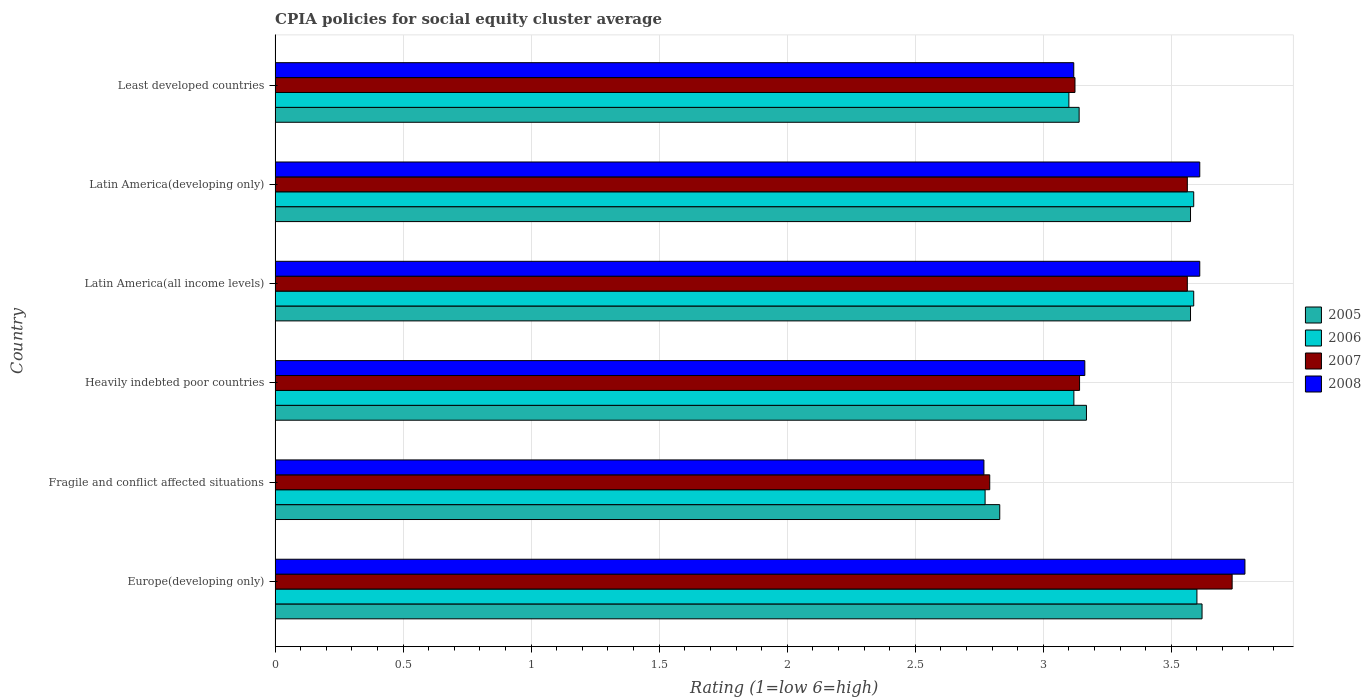How many groups of bars are there?
Offer a terse response. 6. How many bars are there on the 5th tick from the top?
Offer a terse response. 4. What is the label of the 5th group of bars from the top?
Provide a short and direct response. Fragile and conflict affected situations. What is the CPIA rating in 2008 in Heavily indebted poor countries?
Your answer should be compact. 3.16. Across all countries, what is the maximum CPIA rating in 2008?
Ensure brevity in your answer.  3.79. Across all countries, what is the minimum CPIA rating in 2005?
Your response must be concise. 2.83. In which country was the CPIA rating in 2005 maximum?
Make the answer very short. Europe(developing only). In which country was the CPIA rating in 2005 minimum?
Your answer should be very brief. Fragile and conflict affected situations. What is the total CPIA rating in 2006 in the graph?
Offer a terse response. 19.77. What is the difference between the CPIA rating in 2008 in Fragile and conflict affected situations and that in Latin America(all income levels)?
Give a very brief answer. -0.84. What is the difference between the CPIA rating in 2006 in Latin America(all income levels) and the CPIA rating in 2005 in Latin America(developing only)?
Ensure brevity in your answer.  0.01. What is the average CPIA rating in 2005 per country?
Make the answer very short. 3.32. What is the difference between the CPIA rating in 2008 and CPIA rating in 2006 in Least developed countries?
Offer a very short reply. 0.02. What is the ratio of the CPIA rating in 2006 in Europe(developing only) to that in Latin America(developing only)?
Offer a very short reply. 1. Is the CPIA rating in 2008 in Latin America(developing only) less than that in Least developed countries?
Make the answer very short. No. What is the difference between the highest and the second highest CPIA rating in 2008?
Keep it short and to the point. 0.18. What is the difference between the highest and the lowest CPIA rating in 2007?
Your response must be concise. 0.95. Is it the case that in every country, the sum of the CPIA rating in 2006 and CPIA rating in 2005 is greater than the sum of CPIA rating in 2008 and CPIA rating in 2007?
Your answer should be very brief. No. What does the 2nd bar from the top in Heavily indebted poor countries represents?
Ensure brevity in your answer.  2007. Is it the case that in every country, the sum of the CPIA rating in 2006 and CPIA rating in 2007 is greater than the CPIA rating in 2008?
Provide a short and direct response. Yes. How many bars are there?
Your response must be concise. 24. How many countries are there in the graph?
Keep it short and to the point. 6. Does the graph contain any zero values?
Your answer should be very brief. No. Does the graph contain grids?
Keep it short and to the point. Yes. Where does the legend appear in the graph?
Your answer should be compact. Center right. How are the legend labels stacked?
Your response must be concise. Vertical. What is the title of the graph?
Your response must be concise. CPIA policies for social equity cluster average. Does "1986" appear as one of the legend labels in the graph?
Keep it short and to the point. No. What is the label or title of the X-axis?
Make the answer very short. Rating (1=low 6=high). What is the Rating (1=low 6=high) in 2005 in Europe(developing only)?
Keep it short and to the point. 3.62. What is the Rating (1=low 6=high) in 2006 in Europe(developing only)?
Provide a short and direct response. 3.6. What is the Rating (1=low 6=high) of 2007 in Europe(developing only)?
Offer a very short reply. 3.74. What is the Rating (1=low 6=high) of 2008 in Europe(developing only)?
Give a very brief answer. 3.79. What is the Rating (1=low 6=high) in 2005 in Fragile and conflict affected situations?
Keep it short and to the point. 2.83. What is the Rating (1=low 6=high) in 2006 in Fragile and conflict affected situations?
Your answer should be compact. 2.77. What is the Rating (1=low 6=high) in 2007 in Fragile and conflict affected situations?
Give a very brief answer. 2.79. What is the Rating (1=low 6=high) in 2008 in Fragile and conflict affected situations?
Provide a succinct answer. 2.77. What is the Rating (1=low 6=high) in 2005 in Heavily indebted poor countries?
Offer a terse response. 3.17. What is the Rating (1=low 6=high) in 2006 in Heavily indebted poor countries?
Give a very brief answer. 3.12. What is the Rating (1=low 6=high) of 2007 in Heavily indebted poor countries?
Your response must be concise. 3.14. What is the Rating (1=low 6=high) of 2008 in Heavily indebted poor countries?
Your response must be concise. 3.16. What is the Rating (1=low 6=high) in 2005 in Latin America(all income levels)?
Offer a terse response. 3.58. What is the Rating (1=low 6=high) in 2006 in Latin America(all income levels)?
Offer a terse response. 3.59. What is the Rating (1=low 6=high) in 2007 in Latin America(all income levels)?
Ensure brevity in your answer.  3.56. What is the Rating (1=low 6=high) in 2008 in Latin America(all income levels)?
Provide a succinct answer. 3.61. What is the Rating (1=low 6=high) in 2005 in Latin America(developing only)?
Your answer should be compact. 3.58. What is the Rating (1=low 6=high) in 2006 in Latin America(developing only)?
Your response must be concise. 3.59. What is the Rating (1=low 6=high) in 2007 in Latin America(developing only)?
Your answer should be compact. 3.56. What is the Rating (1=low 6=high) in 2008 in Latin America(developing only)?
Provide a succinct answer. 3.61. What is the Rating (1=low 6=high) of 2005 in Least developed countries?
Offer a terse response. 3.14. What is the Rating (1=low 6=high) in 2007 in Least developed countries?
Provide a short and direct response. 3.12. What is the Rating (1=low 6=high) in 2008 in Least developed countries?
Ensure brevity in your answer.  3.12. Across all countries, what is the maximum Rating (1=low 6=high) of 2005?
Ensure brevity in your answer.  3.62. Across all countries, what is the maximum Rating (1=low 6=high) of 2006?
Provide a short and direct response. 3.6. Across all countries, what is the maximum Rating (1=low 6=high) in 2007?
Your response must be concise. 3.74. Across all countries, what is the maximum Rating (1=low 6=high) in 2008?
Provide a succinct answer. 3.79. Across all countries, what is the minimum Rating (1=low 6=high) in 2005?
Provide a short and direct response. 2.83. Across all countries, what is the minimum Rating (1=low 6=high) of 2006?
Provide a short and direct response. 2.77. Across all countries, what is the minimum Rating (1=low 6=high) in 2007?
Your answer should be very brief. 2.79. Across all countries, what is the minimum Rating (1=low 6=high) of 2008?
Offer a terse response. 2.77. What is the total Rating (1=low 6=high) of 2005 in the graph?
Offer a very short reply. 19.91. What is the total Rating (1=low 6=high) of 2006 in the graph?
Offer a terse response. 19.77. What is the total Rating (1=low 6=high) in 2007 in the graph?
Your answer should be compact. 19.92. What is the total Rating (1=low 6=high) in 2008 in the graph?
Your response must be concise. 20.06. What is the difference between the Rating (1=low 6=high) in 2005 in Europe(developing only) and that in Fragile and conflict affected situations?
Your answer should be very brief. 0.79. What is the difference between the Rating (1=low 6=high) of 2006 in Europe(developing only) and that in Fragile and conflict affected situations?
Offer a terse response. 0.83. What is the difference between the Rating (1=low 6=high) in 2007 in Europe(developing only) and that in Fragile and conflict affected situations?
Provide a short and direct response. 0.95. What is the difference between the Rating (1=low 6=high) of 2008 in Europe(developing only) and that in Fragile and conflict affected situations?
Make the answer very short. 1.02. What is the difference between the Rating (1=low 6=high) in 2005 in Europe(developing only) and that in Heavily indebted poor countries?
Offer a terse response. 0.45. What is the difference between the Rating (1=low 6=high) in 2006 in Europe(developing only) and that in Heavily indebted poor countries?
Your answer should be compact. 0.48. What is the difference between the Rating (1=low 6=high) in 2007 in Europe(developing only) and that in Heavily indebted poor countries?
Give a very brief answer. 0.6. What is the difference between the Rating (1=low 6=high) in 2008 in Europe(developing only) and that in Heavily indebted poor countries?
Offer a terse response. 0.63. What is the difference between the Rating (1=low 6=high) of 2005 in Europe(developing only) and that in Latin America(all income levels)?
Provide a short and direct response. 0.04. What is the difference between the Rating (1=low 6=high) in 2006 in Europe(developing only) and that in Latin America(all income levels)?
Make the answer very short. 0.01. What is the difference between the Rating (1=low 6=high) of 2007 in Europe(developing only) and that in Latin America(all income levels)?
Offer a terse response. 0.17. What is the difference between the Rating (1=low 6=high) of 2008 in Europe(developing only) and that in Latin America(all income levels)?
Your answer should be very brief. 0.18. What is the difference between the Rating (1=low 6=high) of 2005 in Europe(developing only) and that in Latin America(developing only)?
Offer a very short reply. 0.04. What is the difference between the Rating (1=low 6=high) of 2006 in Europe(developing only) and that in Latin America(developing only)?
Offer a terse response. 0.01. What is the difference between the Rating (1=low 6=high) in 2007 in Europe(developing only) and that in Latin America(developing only)?
Give a very brief answer. 0.17. What is the difference between the Rating (1=low 6=high) in 2008 in Europe(developing only) and that in Latin America(developing only)?
Provide a short and direct response. 0.18. What is the difference between the Rating (1=low 6=high) of 2005 in Europe(developing only) and that in Least developed countries?
Offer a very short reply. 0.48. What is the difference between the Rating (1=low 6=high) of 2006 in Europe(developing only) and that in Least developed countries?
Give a very brief answer. 0.5. What is the difference between the Rating (1=low 6=high) in 2007 in Europe(developing only) and that in Least developed countries?
Offer a terse response. 0.61. What is the difference between the Rating (1=low 6=high) of 2008 in Europe(developing only) and that in Least developed countries?
Your answer should be very brief. 0.67. What is the difference between the Rating (1=low 6=high) of 2005 in Fragile and conflict affected situations and that in Heavily indebted poor countries?
Offer a terse response. -0.34. What is the difference between the Rating (1=low 6=high) in 2006 in Fragile and conflict affected situations and that in Heavily indebted poor countries?
Offer a very short reply. -0.35. What is the difference between the Rating (1=low 6=high) of 2007 in Fragile and conflict affected situations and that in Heavily indebted poor countries?
Provide a short and direct response. -0.35. What is the difference between the Rating (1=low 6=high) of 2008 in Fragile and conflict affected situations and that in Heavily indebted poor countries?
Give a very brief answer. -0.39. What is the difference between the Rating (1=low 6=high) in 2005 in Fragile and conflict affected situations and that in Latin America(all income levels)?
Offer a very short reply. -0.74. What is the difference between the Rating (1=low 6=high) in 2006 in Fragile and conflict affected situations and that in Latin America(all income levels)?
Provide a succinct answer. -0.81. What is the difference between the Rating (1=low 6=high) of 2007 in Fragile and conflict affected situations and that in Latin America(all income levels)?
Your answer should be compact. -0.77. What is the difference between the Rating (1=low 6=high) in 2008 in Fragile and conflict affected situations and that in Latin America(all income levels)?
Provide a short and direct response. -0.84. What is the difference between the Rating (1=low 6=high) of 2005 in Fragile and conflict affected situations and that in Latin America(developing only)?
Keep it short and to the point. -0.74. What is the difference between the Rating (1=low 6=high) of 2006 in Fragile and conflict affected situations and that in Latin America(developing only)?
Offer a terse response. -0.81. What is the difference between the Rating (1=low 6=high) in 2007 in Fragile and conflict affected situations and that in Latin America(developing only)?
Ensure brevity in your answer.  -0.77. What is the difference between the Rating (1=low 6=high) of 2008 in Fragile and conflict affected situations and that in Latin America(developing only)?
Offer a very short reply. -0.84. What is the difference between the Rating (1=low 6=high) of 2005 in Fragile and conflict affected situations and that in Least developed countries?
Provide a succinct answer. -0.31. What is the difference between the Rating (1=low 6=high) in 2006 in Fragile and conflict affected situations and that in Least developed countries?
Make the answer very short. -0.33. What is the difference between the Rating (1=low 6=high) of 2007 in Fragile and conflict affected situations and that in Least developed countries?
Your answer should be very brief. -0.33. What is the difference between the Rating (1=low 6=high) in 2008 in Fragile and conflict affected situations and that in Least developed countries?
Provide a short and direct response. -0.35. What is the difference between the Rating (1=low 6=high) in 2005 in Heavily indebted poor countries and that in Latin America(all income levels)?
Your response must be concise. -0.41. What is the difference between the Rating (1=low 6=high) in 2006 in Heavily indebted poor countries and that in Latin America(all income levels)?
Your response must be concise. -0.47. What is the difference between the Rating (1=low 6=high) of 2007 in Heavily indebted poor countries and that in Latin America(all income levels)?
Give a very brief answer. -0.42. What is the difference between the Rating (1=low 6=high) in 2008 in Heavily indebted poor countries and that in Latin America(all income levels)?
Your answer should be compact. -0.45. What is the difference between the Rating (1=low 6=high) of 2005 in Heavily indebted poor countries and that in Latin America(developing only)?
Keep it short and to the point. -0.41. What is the difference between the Rating (1=low 6=high) in 2006 in Heavily indebted poor countries and that in Latin America(developing only)?
Your answer should be very brief. -0.47. What is the difference between the Rating (1=low 6=high) of 2007 in Heavily indebted poor countries and that in Latin America(developing only)?
Your response must be concise. -0.42. What is the difference between the Rating (1=low 6=high) of 2008 in Heavily indebted poor countries and that in Latin America(developing only)?
Ensure brevity in your answer.  -0.45. What is the difference between the Rating (1=low 6=high) of 2005 in Heavily indebted poor countries and that in Least developed countries?
Provide a succinct answer. 0.03. What is the difference between the Rating (1=low 6=high) in 2006 in Heavily indebted poor countries and that in Least developed countries?
Provide a short and direct response. 0.02. What is the difference between the Rating (1=low 6=high) of 2007 in Heavily indebted poor countries and that in Least developed countries?
Your answer should be compact. 0.02. What is the difference between the Rating (1=low 6=high) of 2008 in Heavily indebted poor countries and that in Least developed countries?
Make the answer very short. 0.04. What is the difference between the Rating (1=low 6=high) of 2005 in Latin America(all income levels) and that in Latin America(developing only)?
Offer a terse response. 0. What is the difference between the Rating (1=low 6=high) of 2006 in Latin America(all income levels) and that in Latin America(developing only)?
Offer a terse response. 0. What is the difference between the Rating (1=low 6=high) of 2008 in Latin America(all income levels) and that in Latin America(developing only)?
Provide a short and direct response. 0. What is the difference between the Rating (1=low 6=high) of 2005 in Latin America(all income levels) and that in Least developed countries?
Your response must be concise. 0.43. What is the difference between the Rating (1=low 6=high) of 2006 in Latin America(all income levels) and that in Least developed countries?
Ensure brevity in your answer.  0.49. What is the difference between the Rating (1=low 6=high) in 2007 in Latin America(all income levels) and that in Least developed countries?
Make the answer very short. 0.44. What is the difference between the Rating (1=low 6=high) of 2008 in Latin America(all income levels) and that in Least developed countries?
Provide a succinct answer. 0.49. What is the difference between the Rating (1=low 6=high) in 2005 in Latin America(developing only) and that in Least developed countries?
Your answer should be very brief. 0.43. What is the difference between the Rating (1=low 6=high) of 2006 in Latin America(developing only) and that in Least developed countries?
Offer a terse response. 0.49. What is the difference between the Rating (1=low 6=high) of 2007 in Latin America(developing only) and that in Least developed countries?
Offer a terse response. 0.44. What is the difference between the Rating (1=low 6=high) of 2008 in Latin America(developing only) and that in Least developed countries?
Your answer should be compact. 0.49. What is the difference between the Rating (1=low 6=high) of 2005 in Europe(developing only) and the Rating (1=low 6=high) of 2006 in Fragile and conflict affected situations?
Offer a terse response. 0.85. What is the difference between the Rating (1=low 6=high) in 2005 in Europe(developing only) and the Rating (1=low 6=high) in 2007 in Fragile and conflict affected situations?
Keep it short and to the point. 0.83. What is the difference between the Rating (1=low 6=high) in 2005 in Europe(developing only) and the Rating (1=low 6=high) in 2008 in Fragile and conflict affected situations?
Offer a terse response. 0.85. What is the difference between the Rating (1=low 6=high) in 2006 in Europe(developing only) and the Rating (1=low 6=high) in 2007 in Fragile and conflict affected situations?
Your answer should be very brief. 0.81. What is the difference between the Rating (1=low 6=high) in 2006 in Europe(developing only) and the Rating (1=low 6=high) in 2008 in Fragile and conflict affected situations?
Ensure brevity in your answer.  0.83. What is the difference between the Rating (1=low 6=high) in 2007 in Europe(developing only) and the Rating (1=low 6=high) in 2008 in Fragile and conflict affected situations?
Give a very brief answer. 0.97. What is the difference between the Rating (1=low 6=high) in 2005 in Europe(developing only) and the Rating (1=low 6=high) in 2006 in Heavily indebted poor countries?
Your answer should be very brief. 0.5. What is the difference between the Rating (1=low 6=high) in 2005 in Europe(developing only) and the Rating (1=low 6=high) in 2007 in Heavily indebted poor countries?
Make the answer very short. 0.48. What is the difference between the Rating (1=low 6=high) in 2005 in Europe(developing only) and the Rating (1=low 6=high) in 2008 in Heavily indebted poor countries?
Ensure brevity in your answer.  0.46. What is the difference between the Rating (1=low 6=high) in 2006 in Europe(developing only) and the Rating (1=low 6=high) in 2007 in Heavily indebted poor countries?
Keep it short and to the point. 0.46. What is the difference between the Rating (1=low 6=high) in 2006 in Europe(developing only) and the Rating (1=low 6=high) in 2008 in Heavily indebted poor countries?
Your response must be concise. 0.44. What is the difference between the Rating (1=low 6=high) in 2007 in Europe(developing only) and the Rating (1=low 6=high) in 2008 in Heavily indebted poor countries?
Your response must be concise. 0.58. What is the difference between the Rating (1=low 6=high) of 2005 in Europe(developing only) and the Rating (1=low 6=high) of 2006 in Latin America(all income levels)?
Provide a short and direct response. 0.03. What is the difference between the Rating (1=low 6=high) of 2005 in Europe(developing only) and the Rating (1=low 6=high) of 2007 in Latin America(all income levels)?
Your answer should be compact. 0.06. What is the difference between the Rating (1=low 6=high) of 2005 in Europe(developing only) and the Rating (1=low 6=high) of 2008 in Latin America(all income levels)?
Your response must be concise. 0.01. What is the difference between the Rating (1=low 6=high) of 2006 in Europe(developing only) and the Rating (1=low 6=high) of 2007 in Latin America(all income levels)?
Offer a very short reply. 0.04. What is the difference between the Rating (1=low 6=high) in 2006 in Europe(developing only) and the Rating (1=low 6=high) in 2008 in Latin America(all income levels)?
Keep it short and to the point. -0.01. What is the difference between the Rating (1=low 6=high) in 2007 in Europe(developing only) and the Rating (1=low 6=high) in 2008 in Latin America(all income levels)?
Offer a terse response. 0.13. What is the difference between the Rating (1=low 6=high) of 2005 in Europe(developing only) and the Rating (1=low 6=high) of 2006 in Latin America(developing only)?
Make the answer very short. 0.03. What is the difference between the Rating (1=low 6=high) of 2005 in Europe(developing only) and the Rating (1=low 6=high) of 2007 in Latin America(developing only)?
Provide a succinct answer. 0.06. What is the difference between the Rating (1=low 6=high) in 2005 in Europe(developing only) and the Rating (1=low 6=high) in 2008 in Latin America(developing only)?
Offer a terse response. 0.01. What is the difference between the Rating (1=low 6=high) in 2006 in Europe(developing only) and the Rating (1=low 6=high) in 2007 in Latin America(developing only)?
Your response must be concise. 0.04. What is the difference between the Rating (1=low 6=high) of 2006 in Europe(developing only) and the Rating (1=low 6=high) of 2008 in Latin America(developing only)?
Provide a succinct answer. -0.01. What is the difference between the Rating (1=low 6=high) in 2007 in Europe(developing only) and the Rating (1=low 6=high) in 2008 in Latin America(developing only)?
Offer a terse response. 0.13. What is the difference between the Rating (1=low 6=high) in 2005 in Europe(developing only) and the Rating (1=low 6=high) in 2006 in Least developed countries?
Give a very brief answer. 0.52. What is the difference between the Rating (1=low 6=high) of 2005 in Europe(developing only) and the Rating (1=low 6=high) of 2007 in Least developed countries?
Your response must be concise. 0.5. What is the difference between the Rating (1=low 6=high) in 2005 in Europe(developing only) and the Rating (1=low 6=high) in 2008 in Least developed countries?
Your answer should be very brief. 0.5. What is the difference between the Rating (1=low 6=high) in 2006 in Europe(developing only) and the Rating (1=low 6=high) in 2007 in Least developed countries?
Keep it short and to the point. 0.48. What is the difference between the Rating (1=low 6=high) in 2006 in Europe(developing only) and the Rating (1=low 6=high) in 2008 in Least developed countries?
Offer a terse response. 0.48. What is the difference between the Rating (1=low 6=high) of 2007 in Europe(developing only) and the Rating (1=low 6=high) of 2008 in Least developed countries?
Ensure brevity in your answer.  0.62. What is the difference between the Rating (1=low 6=high) in 2005 in Fragile and conflict affected situations and the Rating (1=low 6=high) in 2006 in Heavily indebted poor countries?
Offer a very short reply. -0.29. What is the difference between the Rating (1=low 6=high) of 2005 in Fragile and conflict affected situations and the Rating (1=low 6=high) of 2007 in Heavily indebted poor countries?
Provide a short and direct response. -0.31. What is the difference between the Rating (1=low 6=high) of 2005 in Fragile and conflict affected situations and the Rating (1=low 6=high) of 2008 in Heavily indebted poor countries?
Your answer should be compact. -0.33. What is the difference between the Rating (1=low 6=high) in 2006 in Fragile and conflict affected situations and the Rating (1=low 6=high) in 2007 in Heavily indebted poor countries?
Offer a terse response. -0.37. What is the difference between the Rating (1=low 6=high) in 2006 in Fragile and conflict affected situations and the Rating (1=low 6=high) in 2008 in Heavily indebted poor countries?
Make the answer very short. -0.39. What is the difference between the Rating (1=low 6=high) in 2007 in Fragile and conflict affected situations and the Rating (1=low 6=high) in 2008 in Heavily indebted poor countries?
Your answer should be very brief. -0.37. What is the difference between the Rating (1=low 6=high) of 2005 in Fragile and conflict affected situations and the Rating (1=low 6=high) of 2006 in Latin America(all income levels)?
Your answer should be compact. -0.76. What is the difference between the Rating (1=low 6=high) in 2005 in Fragile and conflict affected situations and the Rating (1=low 6=high) in 2007 in Latin America(all income levels)?
Offer a terse response. -0.73. What is the difference between the Rating (1=low 6=high) of 2005 in Fragile and conflict affected situations and the Rating (1=low 6=high) of 2008 in Latin America(all income levels)?
Offer a very short reply. -0.78. What is the difference between the Rating (1=low 6=high) of 2006 in Fragile and conflict affected situations and the Rating (1=low 6=high) of 2007 in Latin America(all income levels)?
Offer a terse response. -0.79. What is the difference between the Rating (1=low 6=high) of 2006 in Fragile and conflict affected situations and the Rating (1=low 6=high) of 2008 in Latin America(all income levels)?
Your answer should be very brief. -0.84. What is the difference between the Rating (1=low 6=high) of 2007 in Fragile and conflict affected situations and the Rating (1=low 6=high) of 2008 in Latin America(all income levels)?
Your response must be concise. -0.82. What is the difference between the Rating (1=low 6=high) in 2005 in Fragile and conflict affected situations and the Rating (1=low 6=high) in 2006 in Latin America(developing only)?
Give a very brief answer. -0.76. What is the difference between the Rating (1=low 6=high) of 2005 in Fragile and conflict affected situations and the Rating (1=low 6=high) of 2007 in Latin America(developing only)?
Keep it short and to the point. -0.73. What is the difference between the Rating (1=low 6=high) in 2005 in Fragile and conflict affected situations and the Rating (1=low 6=high) in 2008 in Latin America(developing only)?
Provide a short and direct response. -0.78. What is the difference between the Rating (1=low 6=high) in 2006 in Fragile and conflict affected situations and the Rating (1=low 6=high) in 2007 in Latin America(developing only)?
Provide a short and direct response. -0.79. What is the difference between the Rating (1=low 6=high) of 2006 in Fragile and conflict affected situations and the Rating (1=low 6=high) of 2008 in Latin America(developing only)?
Your answer should be compact. -0.84. What is the difference between the Rating (1=low 6=high) in 2007 in Fragile and conflict affected situations and the Rating (1=low 6=high) in 2008 in Latin America(developing only)?
Provide a short and direct response. -0.82. What is the difference between the Rating (1=low 6=high) of 2005 in Fragile and conflict affected situations and the Rating (1=low 6=high) of 2006 in Least developed countries?
Offer a very short reply. -0.27. What is the difference between the Rating (1=low 6=high) in 2005 in Fragile and conflict affected situations and the Rating (1=low 6=high) in 2007 in Least developed countries?
Offer a terse response. -0.29. What is the difference between the Rating (1=low 6=high) in 2005 in Fragile and conflict affected situations and the Rating (1=low 6=high) in 2008 in Least developed countries?
Make the answer very short. -0.29. What is the difference between the Rating (1=low 6=high) of 2006 in Fragile and conflict affected situations and the Rating (1=low 6=high) of 2007 in Least developed countries?
Ensure brevity in your answer.  -0.35. What is the difference between the Rating (1=low 6=high) of 2006 in Fragile and conflict affected situations and the Rating (1=low 6=high) of 2008 in Least developed countries?
Your answer should be very brief. -0.35. What is the difference between the Rating (1=low 6=high) of 2007 in Fragile and conflict affected situations and the Rating (1=low 6=high) of 2008 in Least developed countries?
Make the answer very short. -0.33. What is the difference between the Rating (1=low 6=high) in 2005 in Heavily indebted poor countries and the Rating (1=low 6=high) in 2006 in Latin America(all income levels)?
Your answer should be very brief. -0.42. What is the difference between the Rating (1=low 6=high) of 2005 in Heavily indebted poor countries and the Rating (1=low 6=high) of 2007 in Latin America(all income levels)?
Make the answer very short. -0.39. What is the difference between the Rating (1=low 6=high) in 2005 in Heavily indebted poor countries and the Rating (1=low 6=high) in 2008 in Latin America(all income levels)?
Offer a terse response. -0.44. What is the difference between the Rating (1=low 6=high) in 2006 in Heavily indebted poor countries and the Rating (1=low 6=high) in 2007 in Latin America(all income levels)?
Keep it short and to the point. -0.44. What is the difference between the Rating (1=low 6=high) in 2006 in Heavily indebted poor countries and the Rating (1=low 6=high) in 2008 in Latin America(all income levels)?
Provide a short and direct response. -0.49. What is the difference between the Rating (1=low 6=high) of 2007 in Heavily indebted poor countries and the Rating (1=low 6=high) of 2008 in Latin America(all income levels)?
Provide a succinct answer. -0.47. What is the difference between the Rating (1=low 6=high) of 2005 in Heavily indebted poor countries and the Rating (1=low 6=high) of 2006 in Latin America(developing only)?
Keep it short and to the point. -0.42. What is the difference between the Rating (1=low 6=high) in 2005 in Heavily indebted poor countries and the Rating (1=low 6=high) in 2007 in Latin America(developing only)?
Offer a very short reply. -0.39. What is the difference between the Rating (1=low 6=high) of 2005 in Heavily indebted poor countries and the Rating (1=low 6=high) of 2008 in Latin America(developing only)?
Offer a very short reply. -0.44. What is the difference between the Rating (1=low 6=high) in 2006 in Heavily indebted poor countries and the Rating (1=low 6=high) in 2007 in Latin America(developing only)?
Offer a very short reply. -0.44. What is the difference between the Rating (1=low 6=high) of 2006 in Heavily indebted poor countries and the Rating (1=low 6=high) of 2008 in Latin America(developing only)?
Offer a very short reply. -0.49. What is the difference between the Rating (1=low 6=high) in 2007 in Heavily indebted poor countries and the Rating (1=low 6=high) in 2008 in Latin America(developing only)?
Offer a terse response. -0.47. What is the difference between the Rating (1=low 6=high) of 2005 in Heavily indebted poor countries and the Rating (1=low 6=high) of 2006 in Least developed countries?
Your answer should be very brief. 0.07. What is the difference between the Rating (1=low 6=high) of 2005 in Heavily indebted poor countries and the Rating (1=low 6=high) of 2007 in Least developed countries?
Ensure brevity in your answer.  0.04. What is the difference between the Rating (1=low 6=high) of 2005 in Heavily indebted poor countries and the Rating (1=low 6=high) of 2008 in Least developed countries?
Make the answer very short. 0.05. What is the difference between the Rating (1=low 6=high) in 2006 in Heavily indebted poor countries and the Rating (1=low 6=high) in 2007 in Least developed countries?
Provide a short and direct response. -0. What is the difference between the Rating (1=low 6=high) in 2006 in Heavily indebted poor countries and the Rating (1=low 6=high) in 2008 in Least developed countries?
Your answer should be compact. 0. What is the difference between the Rating (1=low 6=high) of 2007 in Heavily indebted poor countries and the Rating (1=low 6=high) of 2008 in Least developed countries?
Keep it short and to the point. 0.02. What is the difference between the Rating (1=low 6=high) of 2005 in Latin America(all income levels) and the Rating (1=low 6=high) of 2006 in Latin America(developing only)?
Offer a very short reply. -0.01. What is the difference between the Rating (1=low 6=high) of 2005 in Latin America(all income levels) and the Rating (1=low 6=high) of 2007 in Latin America(developing only)?
Offer a terse response. 0.01. What is the difference between the Rating (1=low 6=high) of 2005 in Latin America(all income levels) and the Rating (1=low 6=high) of 2008 in Latin America(developing only)?
Provide a short and direct response. -0.04. What is the difference between the Rating (1=low 6=high) of 2006 in Latin America(all income levels) and the Rating (1=low 6=high) of 2007 in Latin America(developing only)?
Your answer should be very brief. 0.03. What is the difference between the Rating (1=low 6=high) in 2006 in Latin America(all income levels) and the Rating (1=low 6=high) in 2008 in Latin America(developing only)?
Your answer should be compact. -0.02. What is the difference between the Rating (1=low 6=high) of 2007 in Latin America(all income levels) and the Rating (1=low 6=high) of 2008 in Latin America(developing only)?
Give a very brief answer. -0.05. What is the difference between the Rating (1=low 6=high) of 2005 in Latin America(all income levels) and the Rating (1=low 6=high) of 2006 in Least developed countries?
Give a very brief answer. 0.47. What is the difference between the Rating (1=low 6=high) in 2005 in Latin America(all income levels) and the Rating (1=low 6=high) in 2007 in Least developed countries?
Your answer should be very brief. 0.45. What is the difference between the Rating (1=low 6=high) of 2005 in Latin America(all income levels) and the Rating (1=low 6=high) of 2008 in Least developed countries?
Provide a short and direct response. 0.46. What is the difference between the Rating (1=low 6=high) of 2006 in Latin America(all income levels) and the Rating (1=low 6=high) of 2007 in Least developed countries?
Give a very brief answer. 0.46. What is the difference between the Rating (1=low 6=high) in 2006 in Latin America(all income levels) and the Rating (1=low 6=high) in 2008 in Least developed countries?
Your response must be concise. 0.47. What is the difference between the Rating (1=low 6=high) of 2007 in Latin America(all income levels) and the Rating (1=low 6=high) of 2008 in Least developed countries?
Ensure brevity in your answer.  0.44. What is the difference between the Rating (1=low 6=high) in 2005 in Latin America(developing only) and the Rating (1=low 6=high) in 2006 in Least developed countries?
Provide a short and direct response. 0.47. What is the difference between the Rating (1=low 6=high) of 2005 in Latin America(developing only) and the Rating (1=low 6=high) of 2007 in Least developed countries?
Your response must be concise. 0.45. What is the difference between the Rating (1=low 6=high) in 2005 in Latin America(developing only) and the Rating (1=low 6=high) in 2008 in Least developed countries?
Your answer should be compact. 0.46. What is the difference between the Rating (1=low 6=high) in 2006 in Latin America(developing only) and the Rating (1=low 6=high) in 2007 in Least developed countries?
Ensure brevity in your answer.  0.46. What is the difference between the Rating (1=low 6=high) in 2006 in Latin America(developing only) and the Rating (1=low 6=high) in 2008 in Least developed countries?
Your answer should be compact. 0.47. What is the difference between the Rating (1=low 6=high) of 2007 in Latin America(developing only) and the Rating (1=low 6=high) of 2008 in Least developed countries?
Provide a short and direct response. 0.44. What is the average Rating (1=low 6=high) of 2005 per country?
Make the answer very short. 3.32. What is the average Rating (1=low 6=high) of 2006 per country?
Offer a very short reply. 3.29. What is the average Rating (1=low 6=high) in 2007 per country?
Offer a very short reply. 3.32. What is the average Rating (1=low 6=high) in 2008 per country?
Your answer should be very brief. 3.34. What is the difference between the Rating (1=low 6=high) of 2005 and Rating (1=low 6=high) of 2007 in Europe(developing only)?
Offer a terse response. -0.12. What is the difference between the Rating (1=low 6=high) of 2005 and Rating (1=low 6=high) of 2008 in Europe(developing only)?
Give a very brief answer. -0.17. What is the difference between the Rating (1=low 6=high) of 2006 and Rating (1=low 6=high) of 2007 in Europe(developing only)?
Ensure brevity in your answer.  -0.14. What is the difference between the Rating (1=low 6=high) in 2006 and Rating (1=low 6=high) in 2008 in Europe(developing only)?
Offer a terse response. -0.19. What is the difference between the Rating (1=low 6=high) in 2005 and Rating (1=low 6=high) in 2006 in Fragile and conflict affected situations?
Provide a short and direct response. 0.06. What is the difference between the Rating (1=low 6=high) of 2005 and Rating (1=low 6=high) of 2007 in Fragile and conflict affected situations?
Make the answer very short. 0.04. What is the difference between the Rating (1=low 6=high) in 2005 and Rating (1=low 6=high) in 2008 in Fragile and conflict affected situations?
Make the answer very short. 0.06. What is the difference between the Rating (1=low 6=high) of 2006 and Rating (1=low 6=high) of 2007 in Fragile and conflict affected situations?
Your answer should be very brief. -0.02. What is the difference between the Rating (1=low 6=high) of 2006 and Rating (1=low 6=high) of 2008 in Fragile and conflict affected situations?
Your answer should be very brief. 0. What is the difference between the Rating (1=low 6=high) of 2007 and Rating (1=low 6=high) of 2008 in Fragile and conflict affected situations?
Make the answer very short. 0.02. What is the difference between the Rating (1=low 6=high) in 2005 and Rating (1=low 6=high) in 2006 in Heavily indebted poor countries?
Offer a terse response. 0.05. What is the difference between the Rating (1=low 6=high) of 2005 and Rating (1=low 6=high) of 2007 in Heavily indebted poor countries?
Make the answer very short. 0.03. What is the difference between the Rating (1=low 6=high) in 2005 and Rating (1=low 6=high) in 2008 in Heavily indebted poor countries?
Your answer should be compact. 0.01. What is the difference between the Rating (1=low 6=high) of 2006 and Rating (1=low 6=high) of 2007 in Heavily indebted poor countries?
Make the answer very short. -0.02. What is the difference between the Rating (1=low 6=high) of 2006 and Rating (1=low 6=high) of 2008 in Heavily indebted poor countries?
Your response must be concise. -0.04. What is the difference between the Rating (1=low 6=high) of 2007 and Rating (1=low 6=high) of 2008 in Heavily indebted poor countries?
Ensure brevity in your answer.  -0.02. What is the difference between the Rating (1=low 6=high) in 2005 and Rating (1=low 6=high) in 2006 in Latin America(all income levels)?
Your response must be concise. -0.01. What is the difference between the Rating (1=low 6=high) in 2005 and Rating (1=low 6=high) in 2007 in Latin America(all income levels)?
Provide a succinct answer. 0.01. What is the difference between the Rating (1=low 6=high) of 2005 and Rating (1=low 6=high) of 2008 in Latin America(all income levels)?
Ensure brevity in your answer.  -0.04. What is the difference between the Rating (1=low 6=high) of 2006 and Rating (1=low 6=high) of 2007 in Latin America(all income levels)?
Your answer should be very brief. 0.03. What is the difference between the Rating (1=low 6=high) in 2006 and Rating (1=low 6=high) in 2008 in Latin America(all income levels)?
Offer a very short reply. -0.02. What is the difference between the Rating (1=low 6=high) in 2007 and Rating (1=low 6=high) in 2008 in Latin America(all income levels)?
Make the answer very short. -0.05. What is the difference between the Rating (1=low 6=high) in 2005 and Rating (1=low 6=high) in 2006 in Latin America(developing only)?
Your answer should be very brief. -0.01. What is the difference between the Rating (1=low 6=high) in 2005 and Rating (1=low 6=high) in 2007 in Latin America(developing only)?
Ensure brevity in your answer.  0.01. What is the difference between the Rating (1=low 6=high) in 2005 and Rating (1=low 6=high) in 2008 in Latin America(developing only)?
Keep it short and to the point. -0.04. What is the difference between the Rating (1=low 6=high) in 2006 and Rating (1=low 6=high) in 2007 in Latin America(developing only)?
Make the answer very short. 0.03. What is the difference between the Rating (1=low 6=high) in 2006 and Rating (1=low 6=high) in 2008 in Latin America(developing only)?
Your answer should be compact. -0.02. What is the difference between the Rating (1=low 6=high) of 2007 and Rating (1=low 6=high) of 2008 in Latin America(developing only)?
Make the answer very short. -0.05. What is the difference between the Rating (1=low 6=high) in 2005 and Rating (1=low 6=high) in 2006 in Least developed countries?
Ensure brevity in your answer.  0.04. What is the difference between the Rating (1=low 6=high) in 2005 and Rating (1=low 6=high) in 2007 in Least developed countries?
Your answer should be compact. 0.02. What is the difference between the Rating (1=low 6=high) in 2005 and Rating (1=low 6=high) in 2008 in Least developed countries?
Provide a short and direct response. 0.02. What is the difference between the Rating (1=low 6=high) in 2006 and Rating (1=low 6=high) in 2007 in Least developed countries?
Keep it short and to the point. -0.02. What is the difference between the Rating (1=low 6=high) in 2006 and Rating (1=low 6=high) in 2008 in Least developed countries?
Provide a short and direct response. -0.02. What is the difference between the Rating (1=low 6=high) of 2007 and Rating (1=low 6=high) of 2008 in Least developed countries?
Offer a very short reply. 0. What is the ratio of the Rating (1=low 6=high) of 2005 in Europe(developing only) to that in Fragile and conflict affected situations?
Give a very brief answer. 1.28. What is the ratio of the Rating (1=low 6=high) of 2006 in Europe(developing only) to that in Fragile and conflict affected situations?
Offer a terse response. 1.3. What is the ratio of the Rating (1=low 6=high) of 2007 in Europe(developing only) to that in Fragile and conflict affected situations?
Your answer should be compact. 1.34. What is the ratio of the Rating (1=low 6=high) of 2008 in Europe(developing only) to that in Fragile and conflict affected situations?
Offer a very short reply. 1.37. What is the ratio of the Rating (1=low 6=high) in 2005 in Europe(developing only) to that in Heavily indebted poor countries?
Offer a very short reply. 1.14. What is the ratio of the Rating (1=low 6=high) in 2006 in Europe(developing only) to that in Heavily indebted poor countries?
Give a very brief answer. 1.15. What is the ratio of the Rating (1=low 6=high) in 2007 in Europe(developing only) to that in Heavily indebted poor countries?
Make the answer very short. 1.19. What is the ratio of the Rating (1=low 6=high) in 2008 in Europe(developing only) to that in Heavily indebted poor countries?
Provide a succinct answer. 1.2. What is the ratio of the Rating (1=low 6=high) of 2005 in Europe(developing only) to that in Latin America(all income levels)?
Your answer should be compact. 1.01. What is the ratio of the Rating (1=low 6=high) of 2006 in Europe(developing only) to that in Latin America(all income levels)?
Your answer should be very brief. 1. What is the ratio of the Rating (1=low 6=high) in 2007 in Europe(developing only) to that in Latin America(all income levels)?
Provide a succinct answer. 1.05. What is the ratio of the Rating (1=low 6=high) in 2008 in Europe(developing only) to that in Latin America(all income levels)?
Offer a very short reply. 1.05. What is the ratio of the Rating (1=low 6=high) in 2005 in Europe(developing only) to that in Latin America(developing only)?
Your answer should be very brief. 1.01. What is the ratio of the Rating (1=low 6=high) in 2007 in Europe(developing only) to that in Latin America(developing only)?
Your answer should be very brief. 1.05. What is the ratio of the Rating (1=low 6=high) in 2008 in Europe(developing only) to that in Latin America(developing only)?
Keep it short and to the point. 1.05. What is the ratio of the Rating (1=low 6=high) of 2005 in Europe(developing only) to that in Least developed countries?
Your answer should be compact. 1.15. What is the ratio of the Rating (1=low 6=high) of 2006 in Europe(developing only) to that in Least developed countries?
Offer a very short reply. 1.16. What is the ratio of the Rating (1=low 6=high) of 2007 in Europe(developing only) to that in Least developed countries?
Make the answer very short. 1.2. What is the ratio of the Rating (1=low 6=high) of 2008 in Europe(developing only) to that in Least developed countries?
Provide a succinct answer. 1.21. What is the ratio of the Rating (1=low 6=high) in 2005 in Fragile and conflict affected situations to that in Heavily indebted poor countries?
Make the answer very short. 0.89. What is the ratio of the Rating (1=low 6=high) in 2006 in Fragile and conflict affected situations to that in Heavily indebted poor countries?
Your response must be concise. 0.89. What is the ratio of the Rating (1=low 6=high) in 2007 in Fragile and conflict affected situations to that in Heavily indebted poor countries?
Your answer should be compact. 0.89. What is the ratio of the Rating (1=low 6=high) of 2008 in Fragile and conflict affected situations to that in Heavily indebted poor countries?
Your response must be concise. 0.88. What is the ratio of the Rating (1=low 6=high) of 2005 in Fragile and conflict affected situations to that in Latin America(all income levels)?
Offer a terse response. 0.79. What is the ratio of the Rating (1=low 6=high) of 2006 in Fragile and conflict affected situations to that in Latin America(all income levels)?
Offer a very short reply. 0.77. What is the ratio of the Rating (1=low 6=high) in 2007 in Fragile and conflict affected situations to that in Latin America(all income levels)?
Keep it short and to the point. 0.78. What is the ratio of the Rating (1=low 6=high) of 2008 in Fragile and conflict affected situations to that in Latin America(all income levels)?
Give a very brief answer. 0.77. What is the ratio of the Rating (1=low 6=high) in 2005 in Fragile and conflict affected situations to that in Latin America(developing only)?
Your answer should be compact. 0.79. What is the ratio of the Rating (1=low 6=high) in 2006 in Fragile and conflict affected situations to that in Latin America(developing only)?
Provide a short and direct response. 0.77. What is the ratio of the Rating (1=low 6=high) in 2007 in Fragile and conflict affected situations to that in Latin America(developing only)?
Provide a succinct answer. 0.78. What is the ratio of the Rating (1=low 6=high) of 2008 in Fragile and conflict affected situations to that in Latin America(developing only)?
Your answer should be very brief. 0.77. What is the ratio of the Rating (1=low 6=high) in 2005 in Fragile and conflict affected situations to that in Least developed countries?
Make the answer very short. 0.9. What is the ratio of the Rating (1=low 6=high) in 2006 in Fragile and conflict affected situations to that in Least developed countries?
Your response must be concise. 0.89. What is the ratio of the Rating (1=low 6=high) in 2007 in Fragile and conflict affected situations to that in Least developed countries?
Ensure brevity in your answer.  0.89. What is the ratio of the Rating (1=low 6=high) of 2008 in Fragile and conflict affected situations to that in Least developed countries?
Offer a very short reply. 0.89. What is the ratio of the Rating (1=low 6=high) in 2005 in Heavily indebted poor countries to that in Latin America(all income levels)?
Offer a terse response. 0.89. What is the ratio of the Rating (1=low 6=high) of 2006 in Heavily indebted poor countries to that in Latin America(all income levels)?
Ensure brevity in your answer.  0.87. What is the ratio of the Rating (1=low 6=high) in 2007 in Heavily indebted poor countries to that in Latin America(all income levels)?
Your response must be concise. 0.88. What is the ratio of the Rating (1=low 6=high) of 2008 in Heavily indebted poor countries to that in Latin America(all income levels)?
Keep it short and to the point. 0.88. What is the ratio of the Rating (1=low 6=high) in 2005 in Heavily indebted poor countries to that in Latin America(developing only)?
Provide a short and direct response. 0.89. What is the ratio of the Rating (1=low 6=high) in 2006 in Heavily indebted poor countries to that in Latin America(developing only)?
Your answer should be compact. 0.87. What is the ratio of the Rating (1=low 6=high) of 2007 in Heavily indebted poor countries to that in Latin America(developing only)?
Make the answer very short. 0.88. What is the ratio of the Rating (1=low 6=high) of 2008 in Heavily indebted poor countries to that in Latin America(developing only)?
Provide a short and direct response. 0.88. What is the ratio of the Rating (1=low 6=high) of 2005 in Heavily indebted poor countries to that in Least developed countries?
Offer a terse response. 1.01. What is the ratio of the Rating (1=low 6=high) of 2006 in Heavily indebted poor countries to that in Least developed countries?
Your answer should be compact. 1.01. What is the ratio of the Rating (1=low 6=high) of 2007 in Heavily indebted poor countries to that in Least developed countries?
Your response must be concise. 1.01. What is the ratio of the Rating (1=low 6=high) of 2008 in Heavily indebted poor countries to that in Least developed countries?
Provide a succinct answer. 1.01. What is the ratio of the Rating (1=low 6=high) in 2005 in Latin America(all income levels) to that in Latin America(developing only)?
Your answer should be compact. 1. What is the ratio of the Rating (1=low 6=high) of 2005 in Latin America(all income levels) to that in Least developed countries?
Make the answer very short. 1.14. What is the ratio of the Rating (1=low 6=high) in 2006 in Latin America(all income levels) to that in Least developed countries?
Your answer should be compact. 1.16. What is the ratio of the Rating (1=low 6=high) of 2007 in Latin America(all income levels) to that in Least developed countries?
Provide a succinct answer. 1.14. What is the ratio of the Rating (1=low 6=high) in 2008 in Latin America(all income levels) to that in Least developed countries?
Offer a very short reply. 1.16. What is the ratio of the Rating (1=low 6=high) in 2005 in Latin America(developing only) to that in Least developed countries?
Your answer should be compact. 1.14. What is the ratio of the Rating (1=low 6=high) of 2006 in Latin America(developing only) to that in Least developed countries?
Provide a short and direct response. 1.16. What is the ratio of the Rating (1=low 6=high) of 2007 in Latin America(developing only) to that in Least developed countries?
Offer a terse response. 1.14. What is the ratio of the Rating (1=low 6=high) of 2008 in Latin America(developing only) to that in Least developed countries?
Ensure brevity in your answer.  1.16. What is the difference between the highest and the second highest Rating (1=low 6=high) in 2005?
Your response must be concise. 0.04. What is the difference between the highest and the second highest Rating (1=low 6=high) in 2006?
Ensure brevity in your answer.  0.01. What is the difference between the highest and the second highest Rating (1=low 6=high) in 2007?
Your answer should be compact. 0.17. What is the difference between the highest and the second highest Rating (1=low 6=high) in 2008?
Your answer should be compact. 0.18. What is the difference between the highest and the lowest Rating (1=low 6=high) in 2005?
Your response must be concise. 0.79. What is the difference between the highest and the lowest Rating (1=low 6=high) of 2006?
Your response must be concise. 0.83. What is the difference between the highest and the lowest Rating (1=low 6=high) of 2007?
Keep it short and to the point. 0.95. What is the difference between the highest and the lowest Rating (1=low 6=high) of 2008?
Ensure brevity in your answer.  1.02. 